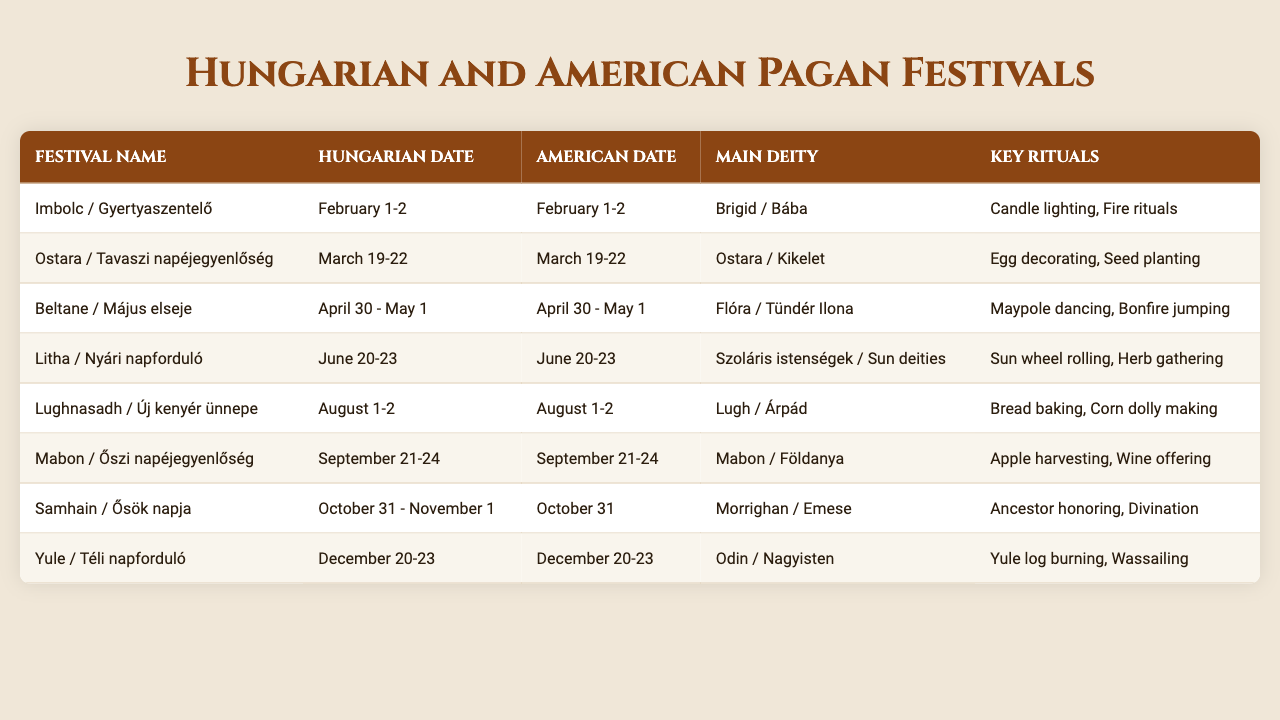What is the date of Mabon in Hungary? According to the table, Mabon is celebrated in Hungary on September 21-24.
Answer: September 21-24 Which festival involves egg decorating? The festival related to egg decorating is Ostara, which appears in the table and is celebrated in both Hungary and America around March 19-22.
Answer: Ostara True or False: Lughnasadh is associated with the deity Brigid. The table shows that Lughnasadh is linked to the deity Lugh, not Brigid. Therefore, the statement is false.
Answer: False How many American festivals occur in October? The table lists two festivals in October: Samhain, observed on October 31 (only one day in America), and combines this with the date range for Samhain in Hungary which is October 31 - November 1. So only one occurs in October in the U.S.
Answer: 1 What are the key rituals for the festival of Litha? From the table, it can be seen that the key rituals for Litha include sun wheel rolling and herb gathering.
Answer: Sun wheel rolling, Herb gathering Which festival occurs on the same dates in both Hungary and America? The table indicates that several festivals align in dates including Imbolc, Ostara, Beltane, Litha, Lughnasadh, Mabon, and Yule, all observed on the same dates in both regions.
Answer: Imbolc, Ostara, Beltane, Litha, Lughnasadh, Mabon, Yule What is the difference in the celebration of Samhain dates between Hungary and America? Referring to the table, Samhain is celebrated on October 31 - November 1 in Hungary and on October 31 in America, indicating that Hungary includes one additional day.
Answer: One additional day in Hungary Which festival is celebrated closest to the Summer Solstice? By examining the festival dates, Litha, celebrated around June 20-23, is closest to the Summer Solstice.
Answer: Litha What is the main deity associated with Yule? The main deity linked to Yule, as stated in the table, is Odin.
Answer: Odin How many festivals have bread-related rituals? According to the table, there are two festivals that include bread-related rituals: Lughnasadh (with bread baking) and Mabon (with wine offering, which often involves bread in traditional settings). Therefore, the count is two.
Answer: 2 What is unique about Samhain's celebration dates in Hungary compared to America? Samhain is celebrated on October 31 - November 1 in Hungary, which makes it unique compared to America where it's only celebrated on October 31. This shows that there's an extra day in Hungary's celebration.
Answer: One extra day in Hungary 